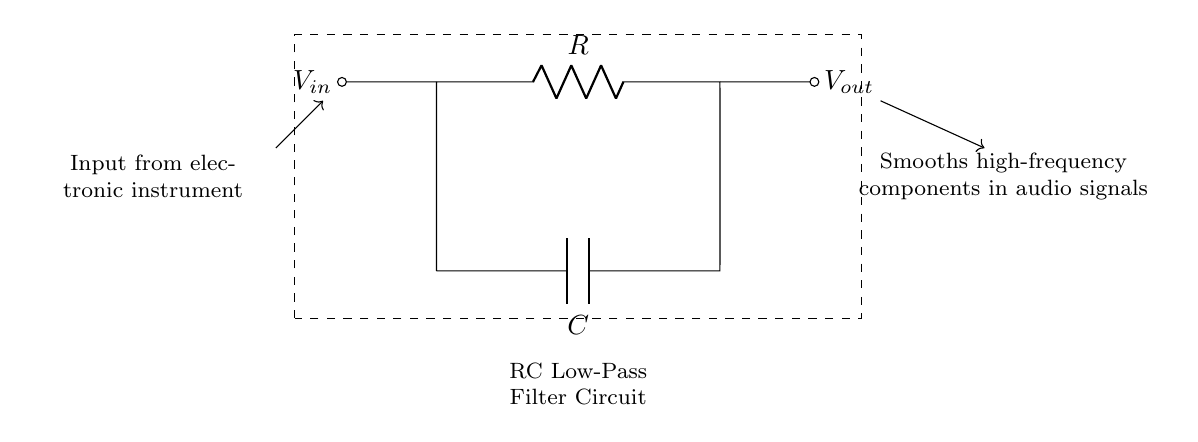What is the type of filter in this circuit? The circuit is an RC low-pass filter, characterized by the presence of a resistor and a capacitor that allow low-frequency signals to pass while attenuating higher frequencies.
Answer: RC low-pass filter What does the capacitor do in this circuit? The capacitor smooths the high-frequency components of the input audio signal, allowing only the low-frequency parts to pass through to the output, which helps in reducing noise.
Answer: Smooths high-frequency components What are the two main components of this circuit? The circuit consists of a resistor and a capacitor, which are essential in determining its filtering characteristics.
Answer: Resistor and capacitor What is the output signal referred to in this circuit? The output signal, denoted as Vout, is the signal that has been processed by the low-pass filter, representing the smoothed version of the input audio signal.
Answer: Vout What is the purpose of the dashed rectangle in the diagram? The dashed rectangle encloses the circuit components and their connections, visually indicating which elements make up the RC low-pass filter circuit used for smoothing audio signals.
Answer: Indicates the circuit boundary What happens to high-frequency signals in this circuit? High-frequency signals are attenuated or reduced at the output, which means they become less pronounced or effectively eliminated, allowing only low-frequency signals through.
Answer: Attenuated 